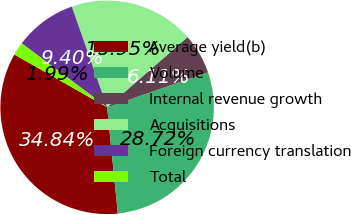Convert chart to OTSL. <chart><loc_0><loc_0><loc_500><loc_500><pie_chart><fcel>Average yield(b)<fcel>Volume<fcel>Internal revenue growth<fcel>Acquisitions<fcel>Foreign currency translation<fcel>Total<nl><fcel>34.84%<fcel>28.72%<fcel>6.11%<fcel>18.95%<fcel>9.4%<fcel>1.99%<nl></chart> 